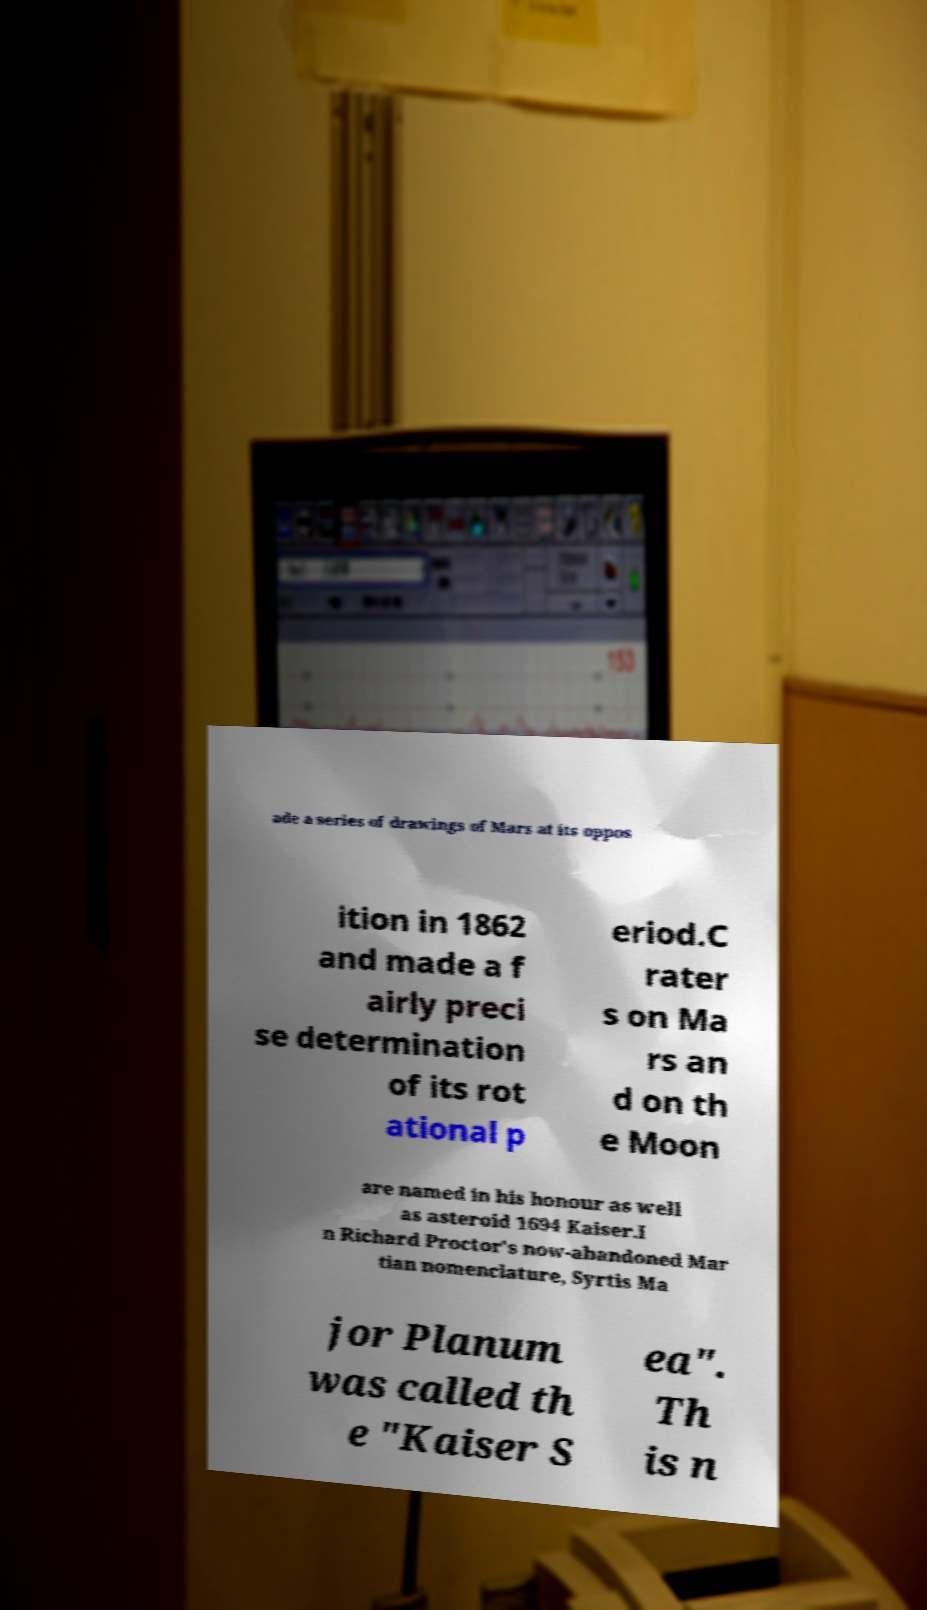I need the written content from this picture converted into text. Can you do that? ade a series of drawings of Mars at its oppos ition in 1862 and made a f airly preci se determination of its rot ational p eriod.C rater s on Ma rs an d on th e Moon are named in his honour as well as asteroid 1694 Kaiser.I n Richard Proctor's now-abandoned Mar tian nomenclature, Syrtis Ma jor Planum was called th e "Kaiser S ea". Th is n 